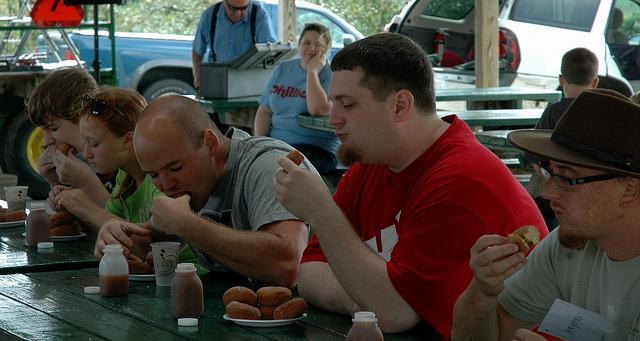How many people are participating in the eating contest?
Give a very brief answer. 5. How many dining tables are in the photo?
Give a very brief answer. 2. How many people can you see?
Give a very brief answer. 8. How many brown cows are in this image?
Give a very brief answer. 0. 